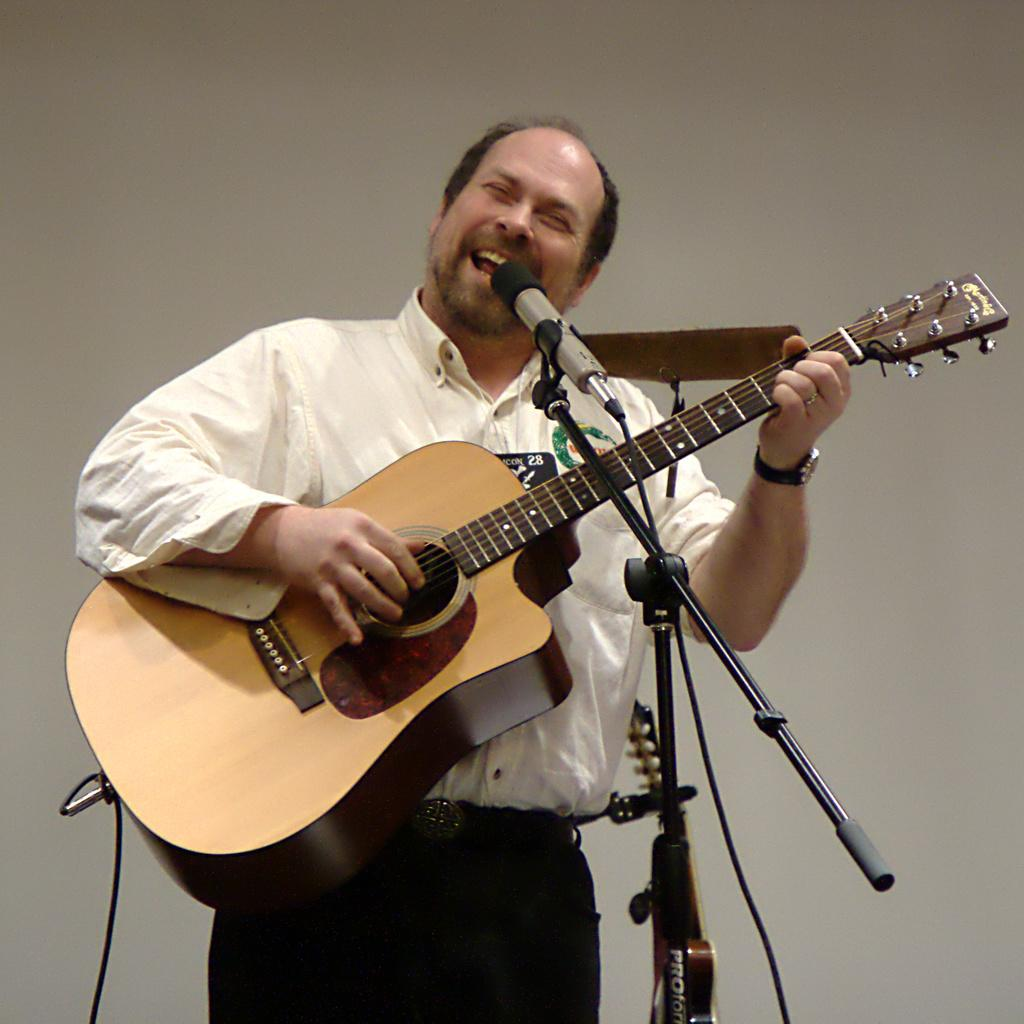What is the main subject of the image? The main subject of the image is a man. What is the man doing in the image? The man is standing, singing a song, and playing a guitar. What object is present in the image that is typically used for amplifying sound? There is a microphone in the image, which is attached to a microphone stand. What type of secretary is sitting next to the man in the image? There is no secretary present in the image; it only features a man singing and playing a guitar, a microphone, and a microphone stand. 